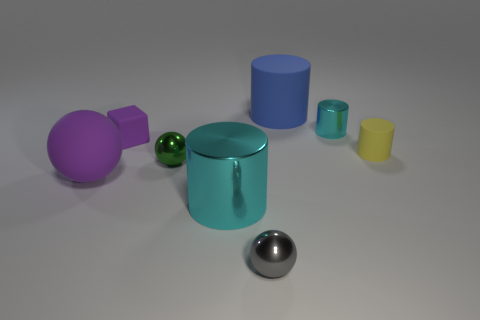Subtract all big metal cylinders. How many cylinders are left? 3 Subtract all cyan cubes. How many cyan cylinders are left? 2 Add 2 purple objects. How many objects exist? 10 Subtract all cyan cylinders. How many cylinders are left? 2 Subtract 1 balls. How many balls are left? 2 Subtract all spheres. How many objects are left? 5 Add 2 tiny matte things. How many tiny matte things are left? 4 Add 7 large purple matte objects. How many large purple matte objects exist? 8 Subtract 0 purple cylinders. How many objects are left? 8 Subtract all green cubes. Subtract all gray cylinders. How many cubes are left? 1 